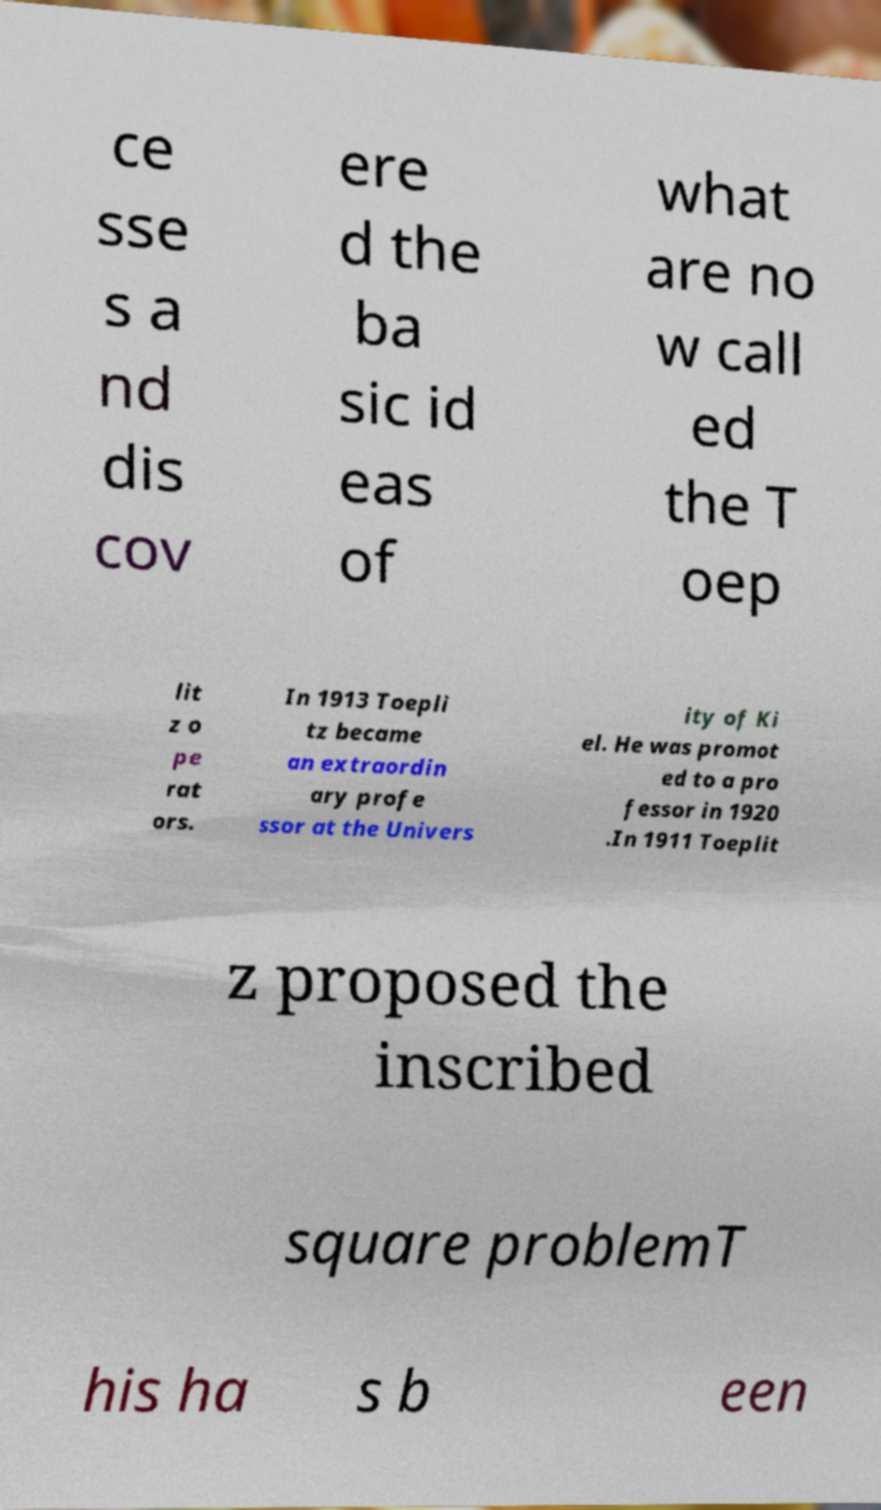Can you accurately transcribe the text from the provided image for me? ce sse s a nd dis cov ere d the ba sic id eas of what are no w call ed the T oep lit z o pe rat ors. In 1913 Toepli tz became an extraordin ary profe ssor at the Univers ity of Ki el. He was promot ed to a pro fessor in 1920 .In 1911 Toeplit z proposed the inscribed square problemT his ha s b een 